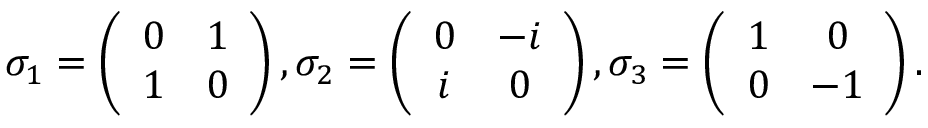Convert formula to latex. <formula><loc_0><loc_0><loc_500><loc_500>\begin{array} { r } { \sigma _ { 1 } = \left ( \begin{array} { c c } { 0 } & { 1 } \\ { 1 } & { 0 } \end{array} \right ) , \sigma _ { 2 } = \left ( \begin{array} { c c } { 0 } & { - i } \\ { i } & { 0 } \end{array} \right ) , \sigma _ { 3 } = \left ( \begin{array} { c c } { 1 } & { 0 } \\ { 0 } & { - 1 } \end{array} \right ) . } \end{array}</formula> 